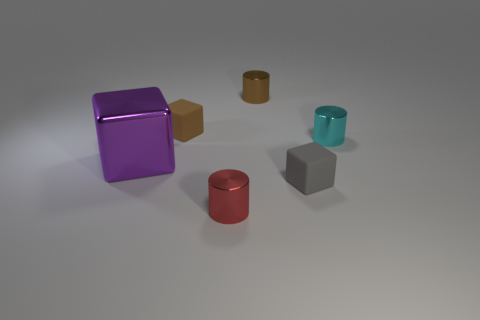Add 3 tiny brown cylinders. How many objects exist? 9 Subtract 0 blue blocks. How many objects are left? 6 Subtract all yellow cylinders. Subtract all tiny brown rubber things. How many objects are left? 5 Add 6 big things. How many big things are left? 7 Add 5 large blue spheres. How many large blue spheres exist? 5 